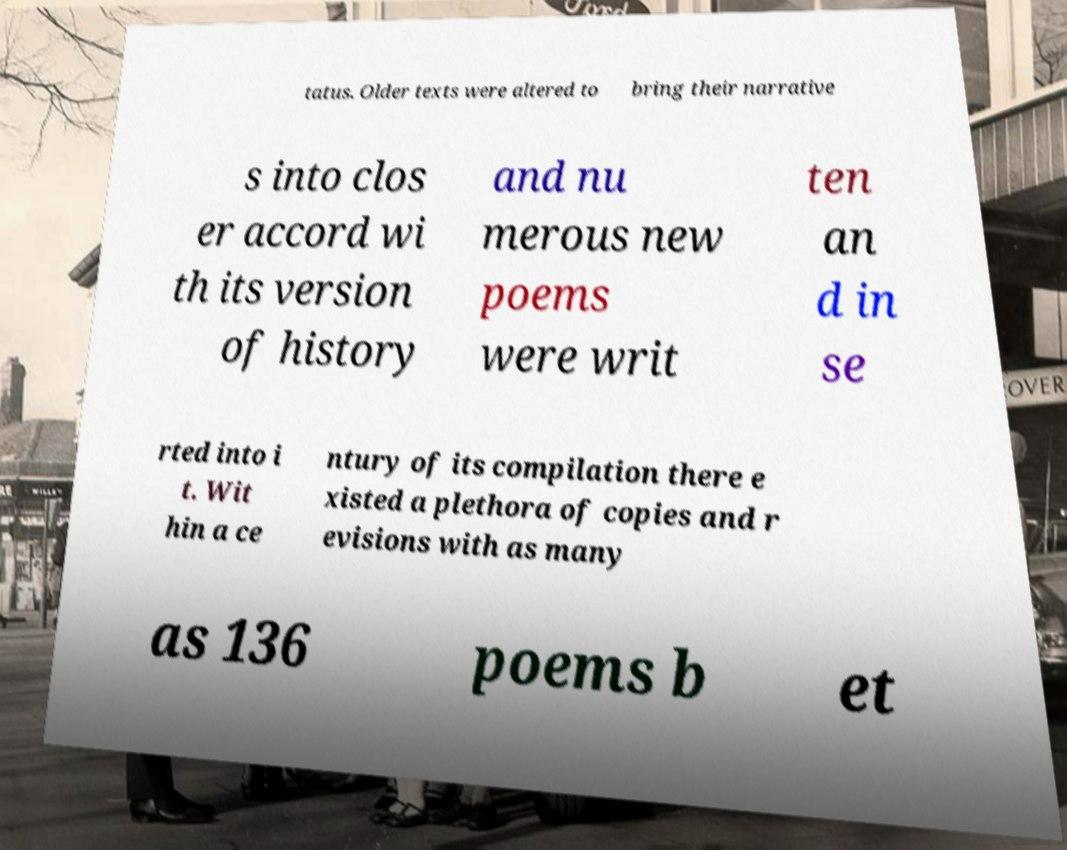I need the written content from this picture converted into text. Can you do that? tatus. Older texts were altered to bring their narrative s into clos er accord wi th its version of history and nu merous new poems were writ ten an d in se rted into i t. Wit hin a ce ntury of its compilation there e xisted a plethora of copies and r evisions with as many as 136 poems b et 